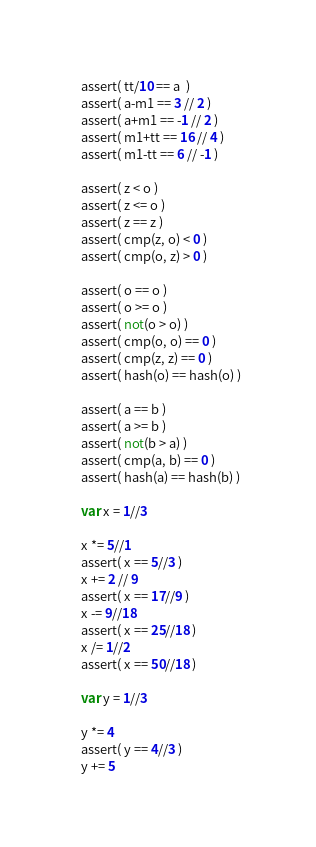Convert code to text. <code><loc_0><loc_0><loc_500><loc_500><_Nim_>  assert( tt/10 == a  )
  assert( a-m1 == 3 // 2 )
  assert( a+m1 == -1 // 2 )
  assert( m1+tt == 16 // 4 )
  assert( m1-tt == 6 // -1 )

  assert( z < o )
  assert( z <= o )
  assert( z == z )
  assert( cmp(z, o) < 0 )
  assert( cmp(o, z) > 0 )

  assert( o == o )
  assert( o >= o )
  assert( not(o > o) )
  assert( cmp(o, o) == 0 )
  assert( cmp(z, z) == 0 )
  assert( hash(o) == hash(o) )

  assert( a == b )
  assert( a >= b )
  assert( not(b > a) )
  assert( cmp(a, b) == 0 )
  assert( hash(a) == hash(b) )

  var x = 1//3

  x *= 5//1
  assert( x == 5//3 )
  x += 2 // 9
  assert( x == 17//9 )
  x -= 9//18
  assert( x == 25//18 )
  x /= 1//2
  assert( x == 50//18 )

  var y = 1//3

  y *= 4
  assert( y == 4//3 )
  y += 5</code> 